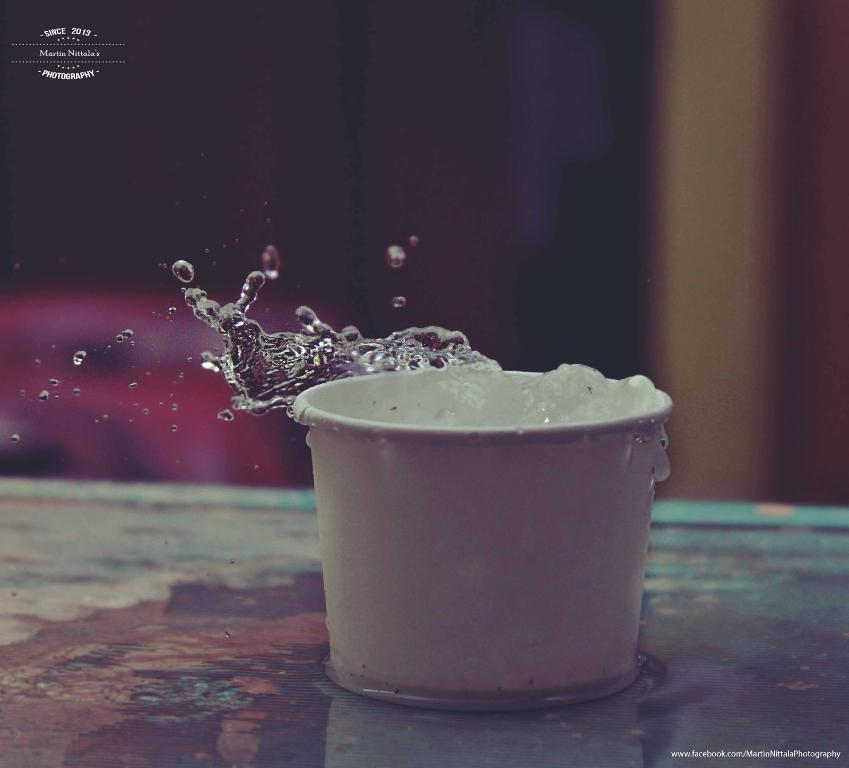What object is visible in the image that can hold liquid? There is a glass in the image that can hold liquid. Where is the glass placed in the image? The glass is placed on a surface in the image. What can be seen around the glass in the image? There is water spillage in the image. What is located at the top left corner of the image? There is a logo at the top left corner of the image. How would you describe the background of the image? The backdrop of the image is blurred. What type of paper is being used to clean up the water spillage in the image? There is no paper visible in the image; it only shows a glass, water spillage, a logo, and a blurred backdrop. 